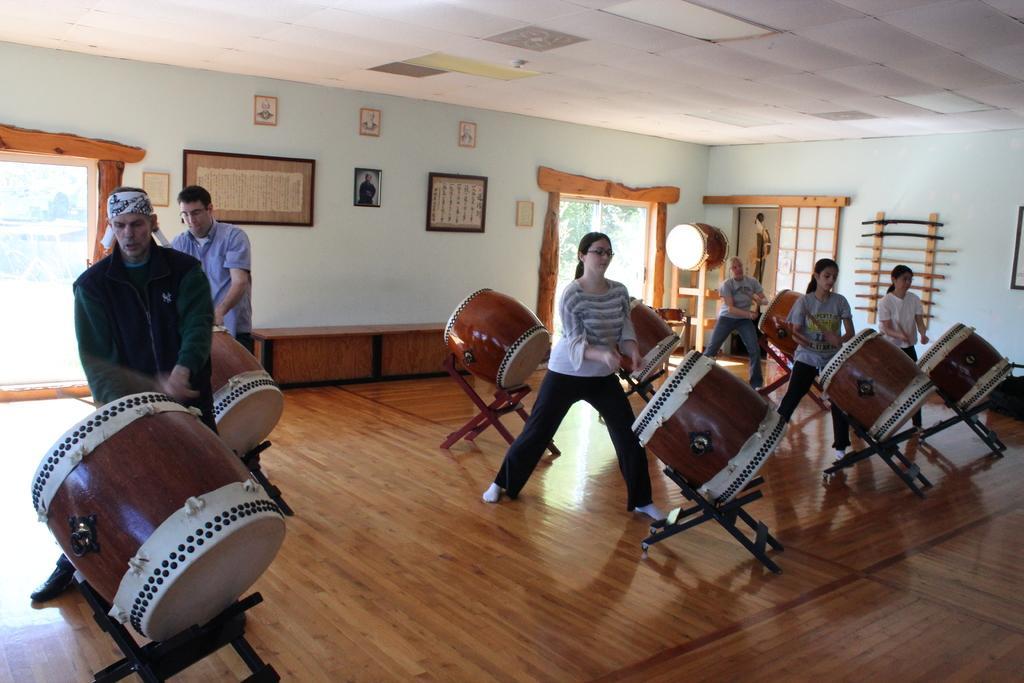Please provide a concise description of this image. In the left middle, there are two person playing drums. In the right middle, there are four persons playing drums. The background wall is sky blue in color. Both side doors are visible and right side window is visible. Roof top is white in color. And on the wall photo frames are there. This image is taken inside a hall. 